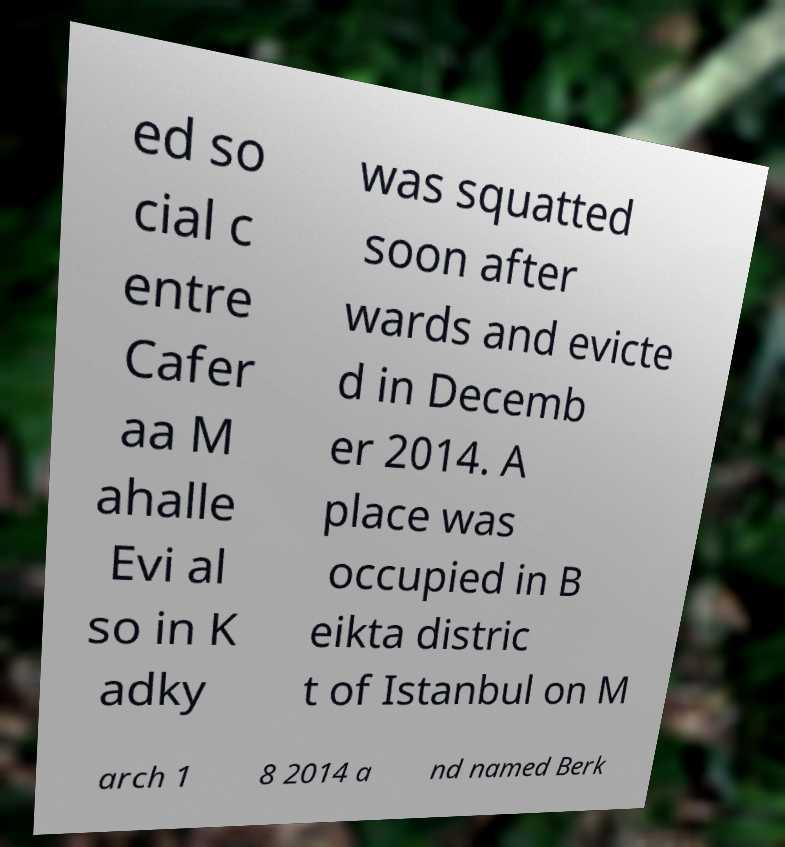What messages or text are displayed in this image? I need them in a readable, typed format. ed so cial c entre Cafer aa M ahalle Evi al so in K adky was squatted soon after wards and evicte d in Decemb er 2014. A place was occupied in B eikta distric t of Istanbul on M arch 1 8 2014 a nd named Berk 